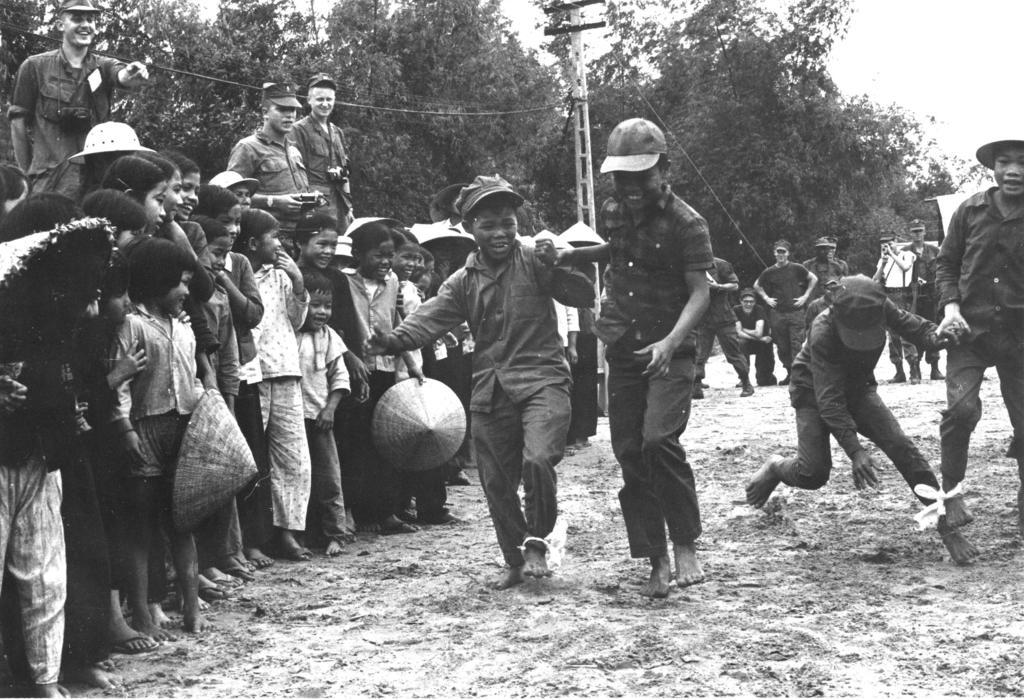What are the people in the image doing? The people in the image are standing on the ground. What are the people wearing on their heads? The people are wearing caps. What can be seen in the background of the image? There are many trees at the back of the image. What color scheme is used in the image? The image is in black and white color. What type of farm animals can be seen grazing in the image? There are no farm animals present in the image; it features people standing on the ground and trees in the background. What is the surprise element in the image? There is no surprise element in the image; it is a straightforward scene of people standing on the ground with trees in the background. 